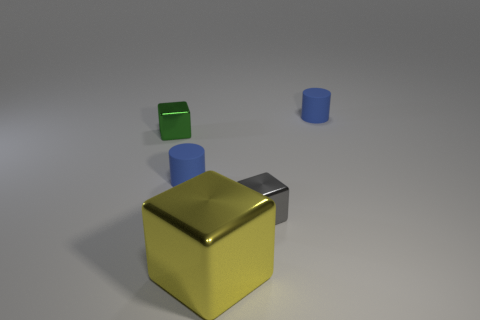Add 2 purple matte cylinders. How many objects exist? 7 Subtract all cylinders. How many objects are left? 3 Add 3 tiny green metal things. How many tiny green metal things are left? 4 Add 3 small blue things. How many small blue things exist? 5 Subtract 0 purple spheres. How many objects are left? 5 Subtract all small metal cubes. Subtract all cubes. How many objects are left? 0 